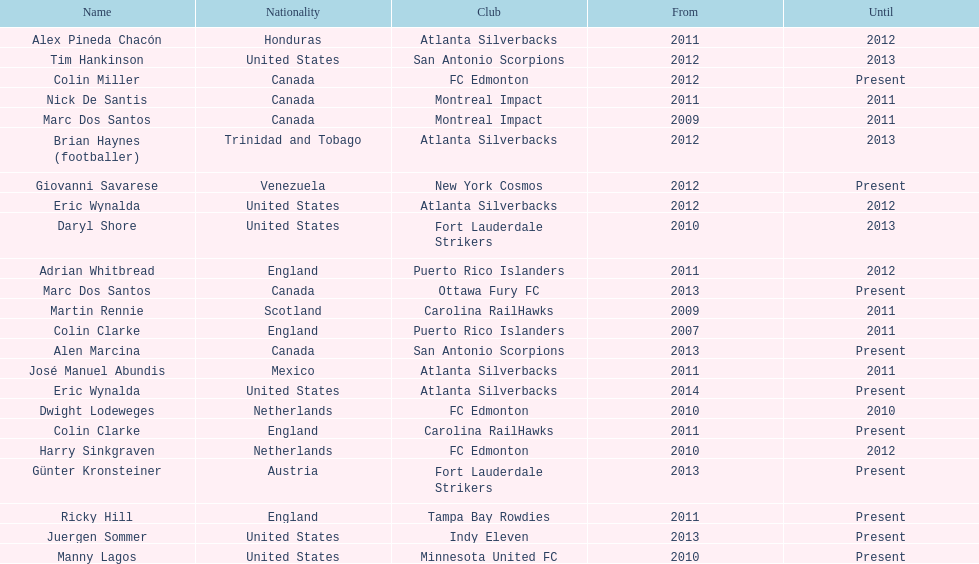How many coaches have coached from america? 6. 